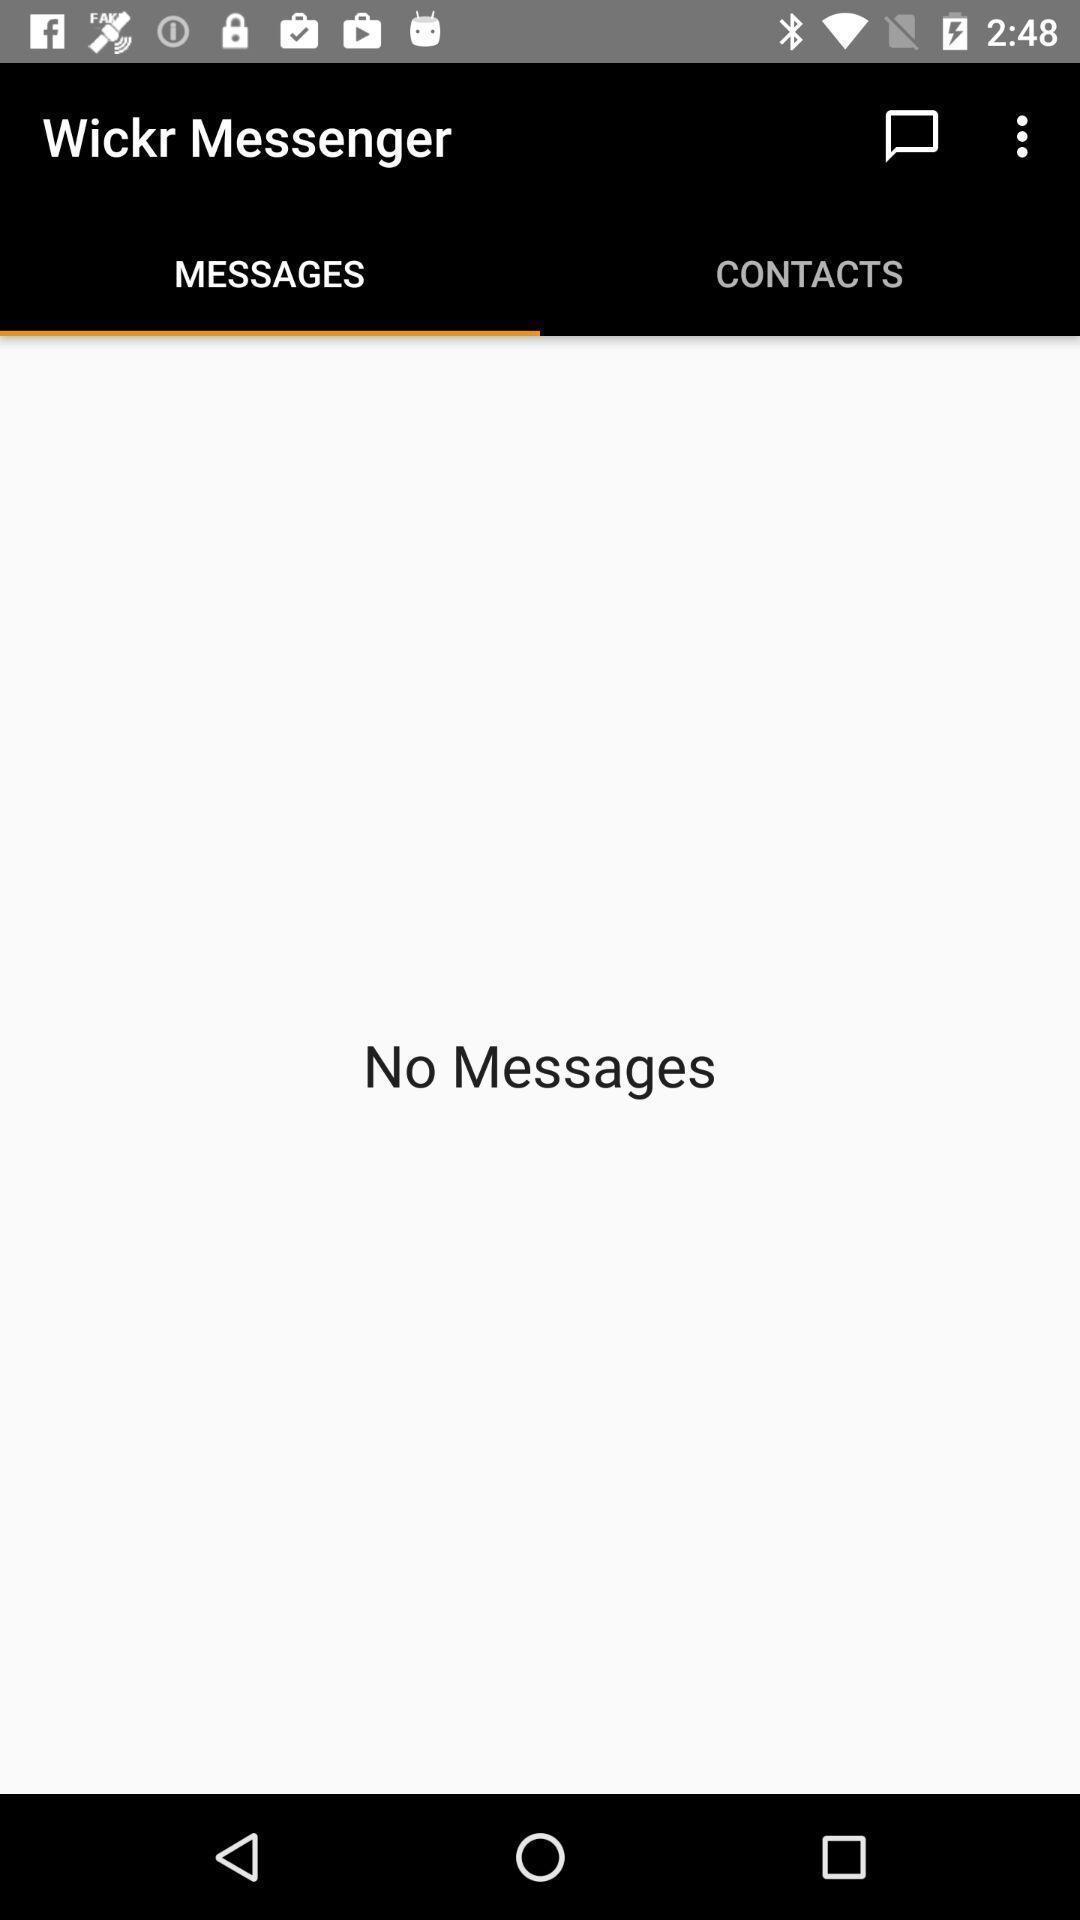Explain the elements present in this screenshot. Screen showing no messages. 